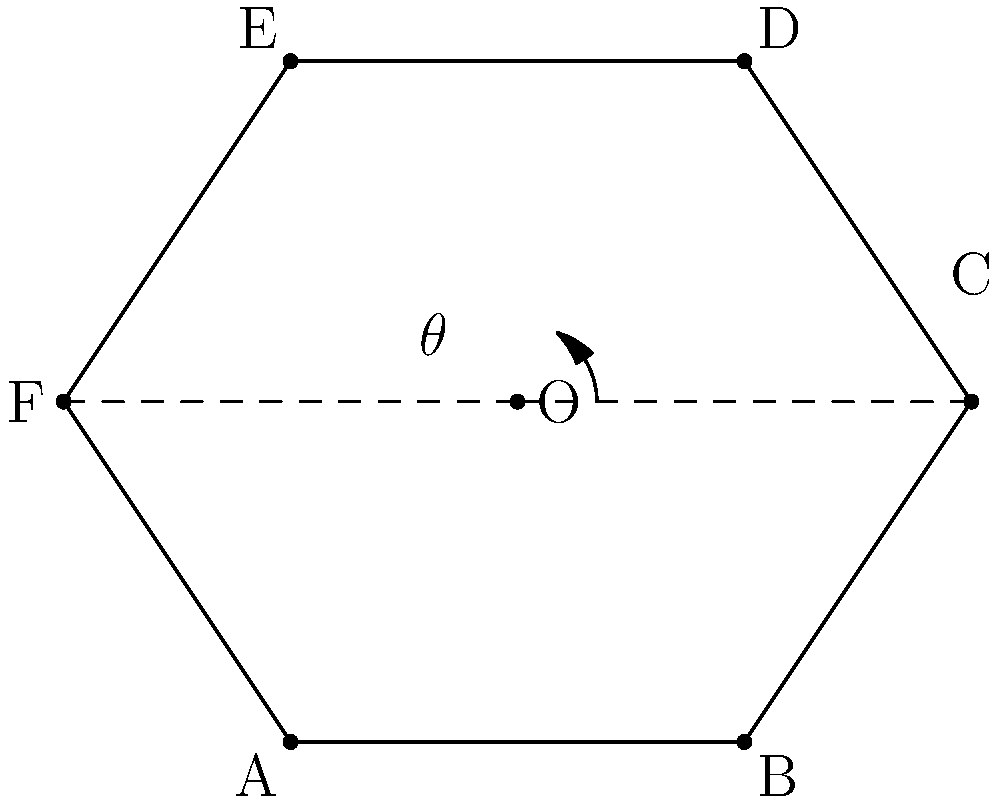In your hexagonal aquarium, you want to find the optimal viewing angle for observing fish behavior. The tank has a center point O, and you're particularly interested in the angle between two adjacent corners. If the tank has a side length of 4 units, what is the measure of angle FOC in degrees? Let's approach this step-by-step:

1) In a regular hexagon, the center point is equidistant from all vertices, forming six equilateral triangles.

2) The internal angle of a regular hexagon is calculated using the formula:
   $$(n-2) \times 180^\circ \div n$$
   where n is the number of sides.
   For a hexagon: $$(6-2) \times 180^\circ \div 6 = 120^\circ$$

3) Each central angle (like FOC) is $360^\circ \div 6 = 60^\circ$

4) We can verify this using the properties of equilateral triangles:
   - Each angle in an equilateral triangle is $60^\circ$
   - The hexagon is made up of 6 equilateral triangles meeting at the center

5) Therefore, regardless of the side length, the angle FOC in a regular hexagon will always be $60^\circ$
Answer: $60^\circ$ 